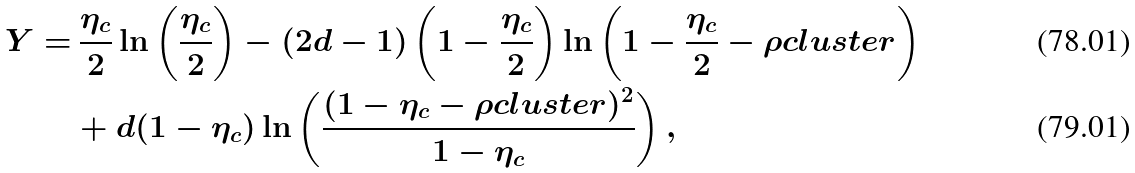<formula> <loc_0><loc_0><loc_500><loc_500>Y = & \, \frac { \eta _ { c } } { 2 } \ln \left ( \frac { \eta _ { c } } { 2 } \right ) - ( 2 d - 1 ) \left ( 1 - \frac { \eta _ { c } } { 2 } \right ) \ln \left ( 1 - \frac { \eta _ { c } } { 2 } - \rho c l u s t e r \right ) \\ & + d ( 1 - \eta _ { c } ) \ln \left ( \frac { ( 1 - \eta _ { c } - \rho c l u s t e r ) ^ { 2 } } { 1 - \eta _ { c } } \right ) ,</formula> 